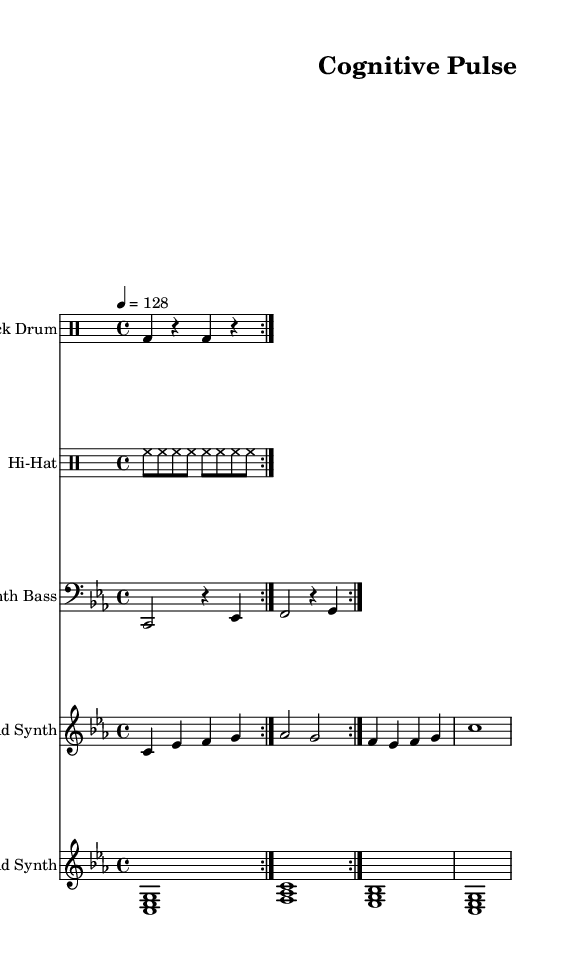What is the key signature of this music? The key signature is C minor, which has three flats (B♭, E♭, and A♭), indicating that the piece is centered around the notes of the C minor scale.
Answer: C minor What is the time signature of this music? The time signature is indicated as 4/4, meaning there are four beats in a measure and the quarter note receives one beat. This is a common time signature in electronic music, allowing for a steady rhythmic pulse.
Answer: 4/4 What is the tempo of this composition? The tempo marking is set at 128 beats per minute, which is typical for minimal techno tracks, providing an energetic pace suitable for dancing.
Answer: 128 How many measures are in the kick drum part? The kick drum part consists of two repetitions of a similar pattern, making a total of 8 measures when counting the beats in repetition. Each repetition contains 4 beats contributing to 4 measures total in the loop.
Answer: 8 Which synth instrument is playing the lead melody? The lead melody is played by the lead synth, which plays a sequence of notes including C, E♭, F, G, A♭, and back to G, creating a melodic line distinct from the other instruments.
Answer: Lead Synth What type of synthesis is most likely used for the pad synth in this piece? The pad synth likely employs subtractive synthesis, which is common in electronic music, utilizing layered chords to create a rich harmonic texture.
Answer: Subtractive synthesis What rhythmic pattern is primarily used in the hi-hat part? The hi-hat part uses a consistent eight-note pattern, with each note playing on the eighth note, creating a driving rhythm typical in techno music.
Answer: Eighth notes 